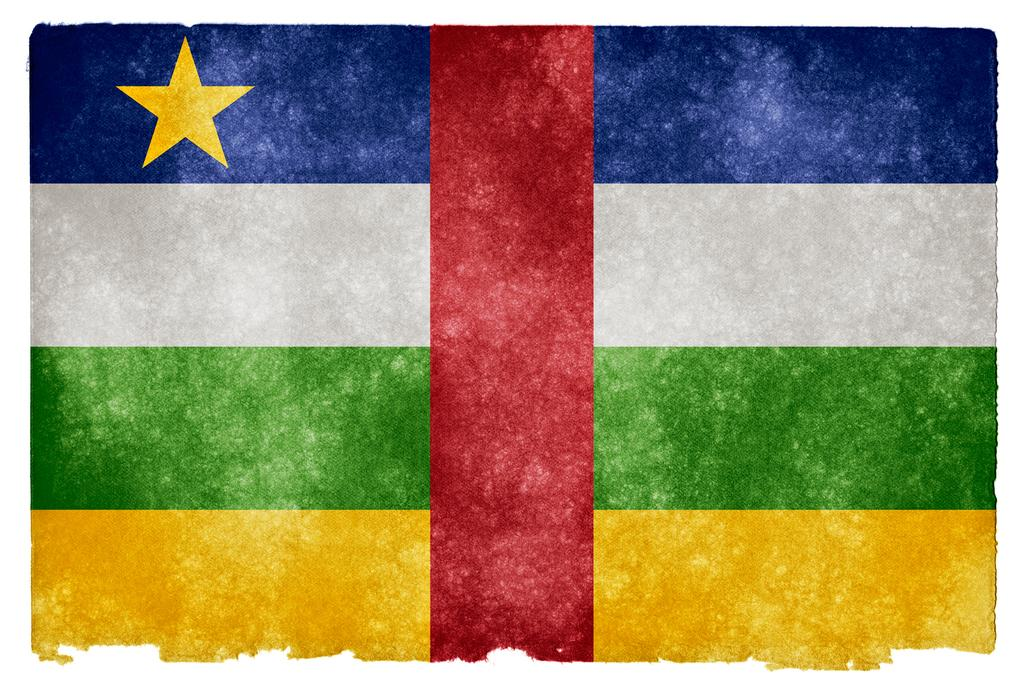What can be observed about the image? The image is edited. What is one specific element present in the image? There is a flag in the image. How many chickens are present in the image? There are no chickens present in the image. What type of song can be heard playing in the background of the image? There is no audio or song present in the image, as it is a still image. 